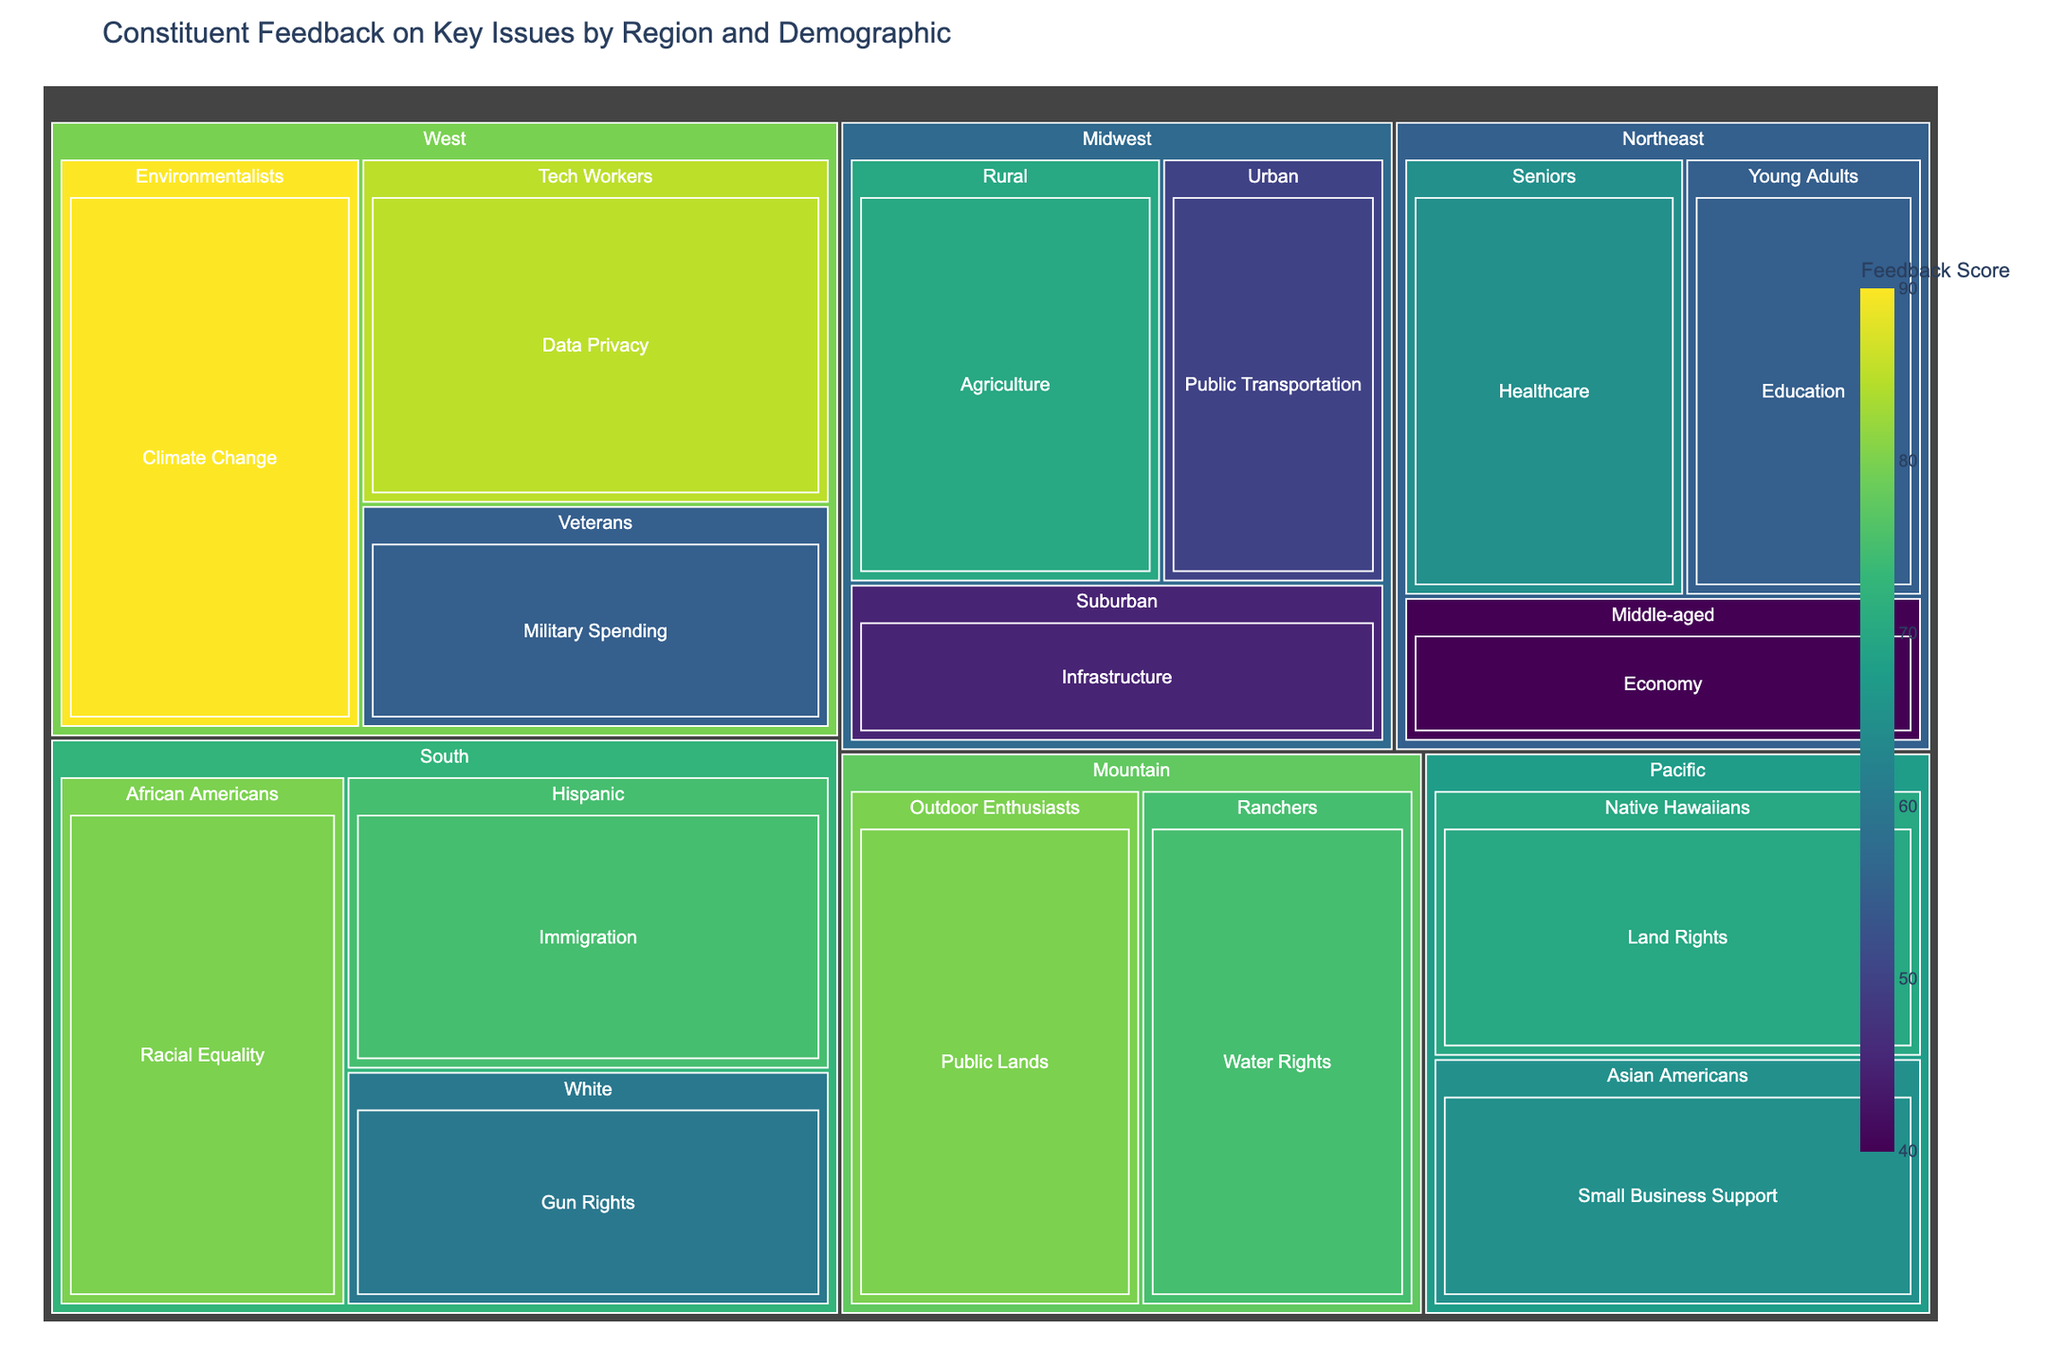What is the title of the treemap? The title is displayed at the top of the figure, providing an overview of what the data represents.
Answer: Constituent Feedback on Key Issues by Region and Demographic Which demographic group in the West has the highest feedback score, and what is the score? Identify the demographic groups in the West region on the treemap, then find the one with the highest feedback score.
Answer: Environmentalists, 90 Compare the feedback scores for Healthcare in the Northeast and Education in the Northeast. Which one is higher, and by how much? Locate the Healthcare and Education segments within the Northeast region and compare their feedback scores: 65 (Healthcare) - 55 (Education).
Answer: Healthcare is higher by 10 points What is the combined feedback score for the issues related to Seniors in the Northeast and Veterans in the West? Add the feedback scores for Seniors in the Healthcare (Northeast) and Veterans in Military Spending (West): 65 + 55.
Answer: 120 Which region shows the highest feedback score, and which issue does it pertain to? Review the treemap for the highest value among all regions and note the corresponding issue.
Answer: West, Climate Change (90) Identify two demographic groups from different regions that focus on public or social issues and compare their feedback scores. Look for demographic groups dealing with public/social issues: Urban (Midwest) with Public Transportation and Young Adults (Northeast) with Education; compare their scores: 50 (Public Transportation) vs. 55 (Education).
Answer: Young Adults (Northeast) score higher by 5 points What feedback score is given for Data Privacy by Tech Workers in the West, and how does it compare to the Agriculture score by Rural in the Midwest? Locate Tech Workers in the West for Data Privacy and Rural in the Midwest for Agriculture, then compare their scores: 85 (Data Privacy) vs. 70 (Agriculture).
Answer: Data Privacy is higher by 15 points Which demographic group in the South has the lowest feedback score, and what is it related to? Identify all demographic groups within the South on the treemap and note the one with the lowest feedback score along with the corresponding issue.
Answer: White, Gun Rights (60) How many different demographic groups are represented in the Midwest region on the treemap? Count the number of distinct demographic groups listed under the Midwest region in the treemap.
Answer: 3 What is the feedback score for Land Rights by Native Hawaiians in the Pacific, and how does it compare to the Water Rights by Ranchers in the Mountain region? Find the feedback scores for Land Rights by Native Hawaiians in the Pacific and Water Rights by Ranchers in the Mountain and compare: 70 (Land Rights) vs. 75 (Water Rights).
Answer: Water Rights is higher by 5 points 